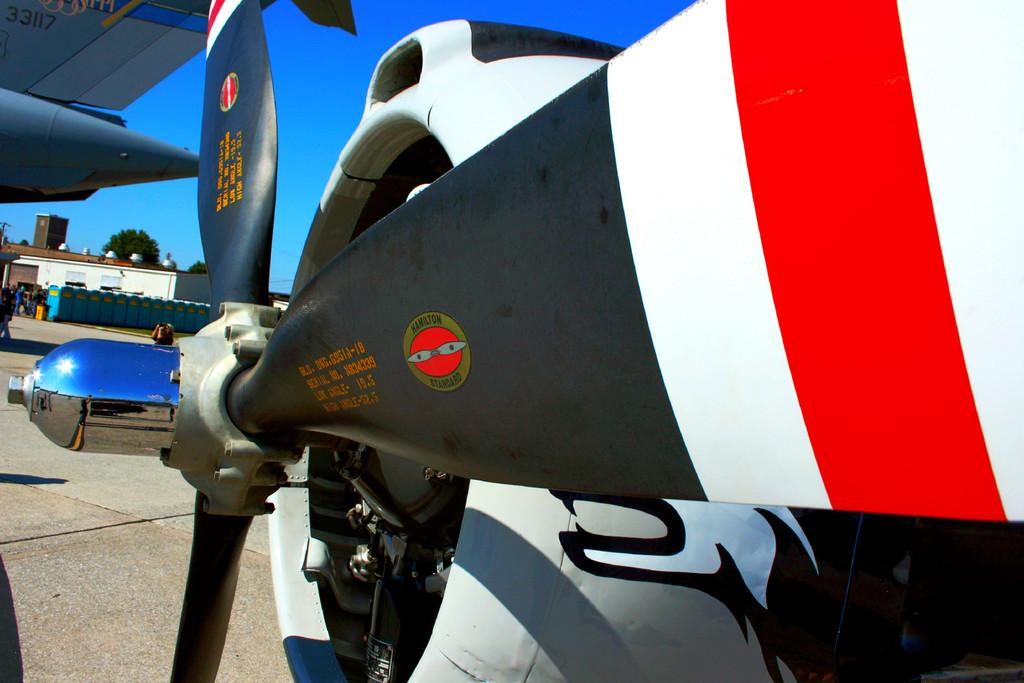Provide a one-sentence caption for the provided image. A Hamilton standard propeller is painted red, white and black. 